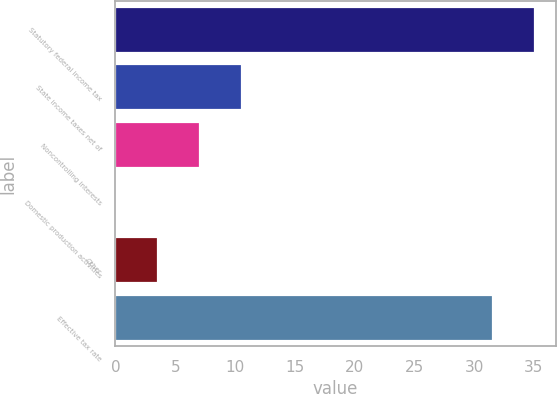Convert chart to OTSL. <chart><loc_0><loc_0><loc_500><loc_500><bar_chart><fcel>Statutory federal income tax<fcel>State income taxes net of<fcel>Noncontrolling interests<fcel>Domestic production activities<fcel>Other<fcel>Effective tax rate<nl><fcel>35.09<fcel>10.57<fcel>7.08<fcel>0.1<fcel>3.59<fcel>31.6<nl></chart> 